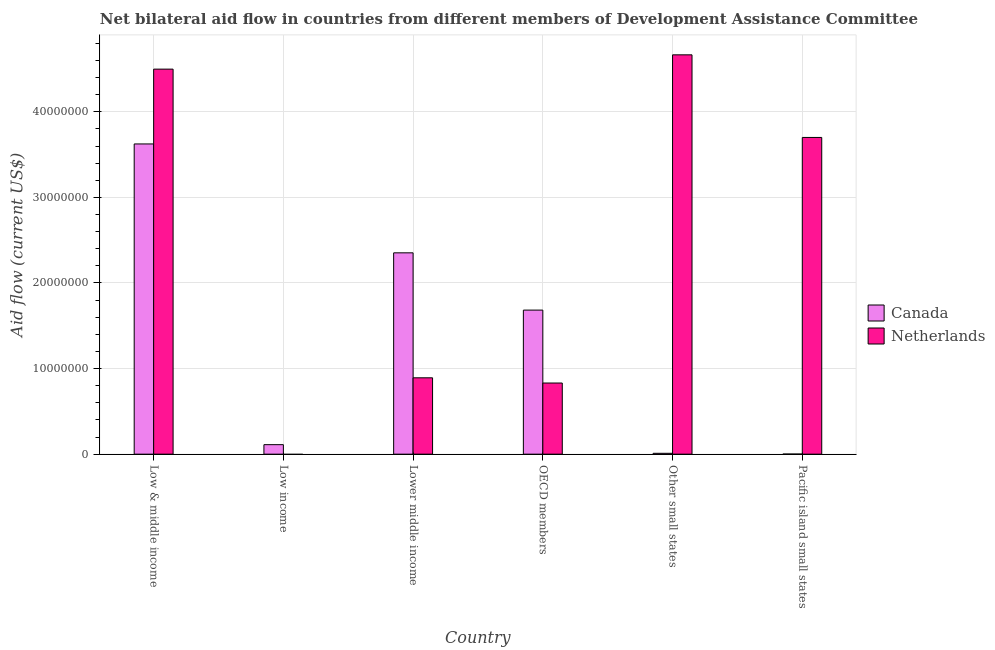How many different coloured bars are there?
Offer a very short reply. 2. Are the number of bars per tick equal to the number of legend labels?
Provide a succinct answer. No. Are the number of bars on each tick of the X-axis equal?
Your answer should be compact. No. What is the label of the 3rd group of bars from the left?
Your answer should be compact. Lower middle income. In how many cases, is the number of bars for a given country not equal to the number of legend labels?
Offer a very short reply. 1. What is the amount of aid given by netherlands in Pacific island small states?
Offer a terse response. 3.70e+07. Across all countries, what is the maximum amount of aid given by netherlands?
Ensure brevity in your answer.  4.66e+07. Across all countries, what is the minimum amount of aid given by canada?
Provide a short and direct response. 10000. What is the total amount of aid given by canada in the graph?
Your answer should be very brief. 7.78e+07. What is the difference between the amount of aid given by canada in Lower middle income and that in Pacific island small states?
Make the answer very short. 2.35e+07. What is the difference between the amount of aid given by netherlands in Low income and the amount of aid given by canada in Other small states?
Offer a very short reply. -1.00e+05. What is the average amount of aid given by netherlands per country?
Ensure brevity in your answer.  2.43e+07. What is the difference between the amount of aid given by netherlands and amount of aid given by canada in Lower middle income?
Provide a short and direct response. -1.46e+07. What is the ratio of the amount of aid given by netherlands in Low & middle income to that in Other small states?
Offer a terse response. 0.96. Is the amount of aid given by netherlands in Low & middle income less than that in Lower middle income?
Offer a very short reply. No. What is the difference between the highest and the second highest amount of aid given by canada?
Keep it short and to the point. 1.27e+07. What is the difference between the highest and the lowest amount of aid given by netherlands?
Ensure brevity in your answer.  4.66e+07. Is the sum of the amount of aid given by netherlands in Lower middle income and OECD members greater than the maximum amount of aid given by canada across all countries?
Keep it short and to the point. No. What is the difference between two consecutive major ticks on the Y-axis?
Offer a terse response. 1.00e+07. Are the values on the major ticks of Y-axis written in scientific E-notation?
Your answer should be very brief. No. Where does the legend appear in the graph?
Make the answer very short. Center right. What is the title of the graph?
Provide a succinct answer. Net bilateral aid flow in countries from different members of Development Assistance Committee. Does "National Visitors" appear as one of the legend labels in the graph?
Your answer should be compact. No. What is the label or title of the X-axis?
Give a very brief answer. Country. What is the label or title of the Y-axis?
Provide a short and direct response. Aid flow (current US$). What is the Aid flow (current US$) in Canada in Low & middle income?
Provide a succinct answer. 3.62e+07. What is the Aid flow (current US$) in Netherlands in Low & middle income?
Your answer should be compact. 4.50e+07. What is the Aid flow (current US$) of Canada in Low income?
Your answer should be compact. 1.11e+06. What is the Aid flow (current US$) in Canada in Lower middle income?
Ensure brevity in your answer.  2.35e+07. What is the Aid flow (current US$) of Netherlands in Lower middle income?
Make the answer very short. 8.92e+06. What is the Aid flow (current US$) in Canada in OECD members?
Your answer should be very brief. 1.68e+07. What is the Aid flow (current US$) of Netherlands in OECD members?
Offer a very short reply. 8.31e+06. What is the Aid flow (current US$) of Canada in Other small states?
Offer a terse response. 1.00e+05. What is the Aid flow (current US$) in Netherlands in Other small states?
Your answer should be very brief. 4.66e+07. What is the Aid flow (current US$) in Netherlands in Pacific island small states?
Keep it short and to the point. 3.70e+07. Across all countries, what is the maximum Aid flow (current US$) of Canada?
Ensure brevity in your answer.  3.62e+07. Across all countries, what is the maximum Aid flow (current US$) in Netherlands?
Your answer should be compact. 4.66e+07. Across all countries, what is the minimum Aid flow (current US$) in Canada?
Ensure brevity in your answer.  10000. Across all countries, what is the minimum Aid flow (current US$) in Netherlands?
Give a very brief answer. 0. What is the total Aid flow (current US$) in Canada in the graph?
Your response must be concise. 7.78e+07. What is the total Aid flow (current US$) of Netherlands in the graph?
Offer a terse response. 1.46e+08. What is the difference between the Aid flow (current US$) of Canada in Low & middle income and that in Low income?
Provide a succinct answer. 3.51e+07. What is the difference between the Aid flow (current US$) of Canada in Low & middle income and that in Lower middle income?
Your answer should be very brief. 1.27e+07. What is the difference between the Aid flow (current US$) of Netherlands in Low & middle income and that in Lower middle income?
Give a very brief answer. 3.61e+07. What is the difference between the Aid flow (current US$) of Canada in Low & middle income and that in OECD members?
Ensure brevity in your answer.  1.94e+07. What is the difference between the Aid flow (current US$) of Netherlands in Low & middle income and that in OECD members?
Ensure brevity in your answer.  3.67e+07. What is the difference between the Aid flow (current US$) of Canada in Low & middle income and that in Other small states?
Your answer should be very brief. 3.61e+07. What is the difference between the Aid flow (current US$) of Netherlands in Low & middle income and that in Other small states?
Give a very brief answer. -1.67e+06. What is the difference between the Aid flow (current US$) in Canada in Low & middle income and that in Pacific island small states?
Offer a terse response. 3.62e+07. What is the difference between the Aid flow (current US$) of Netherlands in Low & middle income and that in Pacific island small states?
Your answer should be compact. 7.98e+06. What is the difference between the Aid flow (current US$) in Canada in Low income and that in Lower middle income?
Provide a short and direct response. -2.24e+07. What is the difference between the Aid flow (current US$) of Canada in Low income and that in OECD members?
Your answer should be compact. -1.57e+07. What is the difference between the Aid flow (current US$) of Canada in Low income and that in Other small states?
Keep it short and to the point. 1.01e+06. What is the difference between the Aid flow (current US$) in Canada in Low income and that in Pacific island small states?
Keep it short and to the point. 1.10e+06. What is the difference between the Aid flow (current US$) in Canada in Lower middle income and that in OECD members?
Offer a terse response. 6.69e+06. What is the difference between the Aid flow (current US$) in Canada in Lower middle income and that in Other small states?
Your answer should be compact. 2.34e+07. What is the difference between the Aid flow (current US$) of Netherlands in Lower middle income and that in Other small states?
Ensure brevity in your answer.  -3.77e+07. What is the difference between the Aid flow (current US$) in Canada in Lower middle income and that in Pacific island small states?
Provide a succinct answer. 2.35e+07. What is the difference between the Aid flow (current US$) in Netherlands in Lower middle income and that in Pacific island small states?
Give a very brief answer. -2.81e+07. What is the difference between the Aid flow (current US$) in Canada in OECD members and that in Other small states?
Make the answer very short. 1.67e+07. What is the difference between the Aid flow (current US$) in Netherlands in OECD members and that in Other small states?
Provide a succinct answer. -3.83e+07. What is the difference between the Aid flow (current US$) of Canada in OECD members and that in Pacific island small states?
Provide a short and direct response. 1.68e+07. What is the difference between the Aid flow (current US$) of Netherlands in OECD members and that in Pacific island small states?
Your answer should be compact. -2.87e+07. What is the difference between the Aid flow (current US$) in Canada in Other small states and that in Pacific island small states?
Keep it short and to the point. 9.00e+04. What is the difference between the Aid flow (current US$) of Netherlands in Other small states and that in Pacific island small states?
Your response must be concise. 9.65e+06. What is the difference between the Aid flow (current US$) of Canada in Low & middle income and the Aid flow (current US$) of Netherlands in Lower middle income?
Offer a very short reply. 2.73e+07. What is the difference between the Aid flow (current US$) of Canada in Low & middle income and the Aid flow (current US$) of Netherlands in OECD members?
Offer a terse response. 2.79e+07. What is the difference between the Aid flow (current US$) in Canada in Low & middle income and the Aid flow (current US$) in Netherlands in Other small states?
Keep it short and to the point. -1.04e+07. What is the difference between the Aid flow (current US$) of Canada in Low & middle income and the Aid flow (current US$) of Netherlands in Pacific island small states?
Provide a short and direct response. -7.60e+05. What is the difference between the Aid flow (current US$) of Canada in Low income and the Aid flow (current US$) of Netherlands in Lower middle income?
Make the answer very short. -7.81e+06. What is the difference between the Aid flow (current US$) in Canada in Low income and the Aid flow (current US$) in Netherlands in OECD members?
Make the answer very short. -7.20e+06. What is the difference between the Aid flow (current US$) of Canada in Low income and the Aid flow (current US$) of Netherlands in Other small states?
Your response must be concise. -4.55e+07. What is the difference between the Aid flow (current US$) in Canada in Low income and the Aid flow (current US$) in Netherlands in Pacific island small states?
Keep it short and to the point. -3.59e+07. What is the difference between the Aid flow (current US$) of Canada in Lower middle income and the Aid flow (current US$) of Netherlands in OECD members?
Your answer should be very brief. 1.52e+07. What is the difference between the Aid flow (current US$) in Canada in Lower middle income and the Aid flow (current US$) in Netherlands in Other small states?
Your response must be concise. -2.31e+07. What is the difference between the Aid flow (current US$) of Canada in Lower middle income and the Aid flow (current US$) of Netherlands in Pacific island small states?
Provide a succinct answer. -1.35e+07. What is the difference between the Aid flow (current US$) in Canada in OECD members and the Aid flow (current US$) in Netherlands in Other small states?
Give a very brief answer. -2.98e+07. What is the difference between the Aid flow (current US$) in Canada in OECD members and the Aid flow (current US$) in Netherlands in Pacific island small states?
Your answer should be compact. -2.02e+07. What is the difference between the Aid flow (current US$) in Canada in Other small states and the Aid flow (current US$) in Netherlands in Pacific island small states?
Make the answer very short. -3.69e+07. What is the average Aid flow (current US$) of Canada per country?
Provide a short and direct response. 1.30e+07. What is the average Aid flow (current US$) of Netherlands per country?
Give a very brief answer. 2.43e+07. What is the difference between the Aid flow (current US$) of Canada and Aid flow (current US$) of Netherlands in Low & middle income?
Ensure brevity in your answer.  -8.74e+06. What is the difference between the Aid flow (current US$) of Canada and Aid flow (current US$) of Netherlands in Lower middle income?
Give a very brief answer. 1.46e+07. What is the difference between the Aid flow (current US$) in Canada and Aid flow (current US$) in Netherlands in OECD members?
Make the answer very short. 8.52e+06. What is the difference between the Aid flow (current US$) of Canada and Aid flow (current US$) of Netherlands in Other small states?
Keep it short and to the point. -4.66e+07. What is the difference between the Aid flow (current US$) of Canada and Aid flow (current US$) of Netherlands in Pacific island small states?
Your answer should be very brief. -3.70e+07. What is the ratio of the Aid flow (current US$) of Canada in Low & middle income to that in Low income?
Provide a succinct answer. 32.65. What is the ratio of the Aid flow (current US$) of Canada in Low & middle income to that in Lower middle income?
Make the answer very short. 1.54. What is the ratio of the Aid flow (current US$) in Netherlands in Low & middle income to that in Lower middle income?
Ensure brevity in your answer.  5.04. What is the ratio of the Aid flow (current US$) of Canada in Low & middle income to that in OECD members?
Ensure brevity in your answer.  2.15. What is the ratio of the Aid flow (current US$) of Netherlands in Low & middle income to that in OECD members?
Provide a succinct answer. 5.41. What is the ratio of the Aid flow (current US$) in Canada in Low & middle income to that in Other small states?
Ensure brevity in your answer.  362.4. What is the ratio of the Aid flow (current US$) of Netherlands in Low & middle income to that in Other small states?
Your response must be concise. 0.96. What is the ratio of the Aid flow (current US$) in Canada in Low & middle income to that in Pacific island small states?
Provide a short and direct response. 3624. What is the ratio of the Aid flow (current US$) in Netherlands in Low & middle income to that in Pacific island small states?
Offer a terse response. 1.22. What is the ratio of the Aid flow (current US$) in Canada in Low income to that in Lower middle income?
Make the answer very short. 0.05. What is the ratio of the Aid flow (current US$) in Canada in Low income to that in OECD members?
Make the answer very short. 0.07. What is the ratio of the Aid flow (current US$) of Canada in Low income to that in Other small states?
Your answer should be compact. 11.1. What is the ratio of the Aid flow (current US$) in Canada in Low income to that in Pacific island small states?
Your answer should be very brief. 111. What is the ratio of the Aid flow (current US$) in Canada in Lower middle income to that in OECD members?
Offer a very short reply. 1.4. What is the ratio of the Aid flow (current US$) in Netherlands in Lower middle income to that in OECD members?
Provide a succinct answer. 1.07. What is the ratio of the Aid flow (current US$) of Canada in Lower middle income to that in Other small states?
Provide a succinct answer. 235.2. What is the ratio of the Aid flow (current US$) in Netherlands in Lower middle income to that in Other small states?
Provide a short and direct response. 0.19. What is the ratio of the Aid flow (current US$) of Canada in Lower middle income to that in Pacific island small states?
Provide a short and direct response. 2352. What is the ratio of the Aid flow (current US$) in Netherlands in Lower middle income to that in Pacific island small states?
Your response must be concise. 0.24. What is the ratio of the Aid flow (current US$) of Canada in OECD members to that in Other small states?
Your answer should be compact. 168.3. What is the ratio of the Aid flow (current US$) in Netherlands in OECD members to that in Other small states?
Offer a very short reply. 0.18. What is the ratio of the Aid flow (current US$) of Canada in OECD members to that in Pacific island small states?
Keep it short and to the point. 1683. What is the ratio of the Aid flow (current US$) in Netherlands in OECD members to that in Pacific island small states?
Offer a very short reply. 0.22. What is the ratio of the Aid flow (current US$) in Canada in Other small states to that in Pacific island small states?
Offer a very short reply. 10. What is the ratio of the Aid flow (current US$) of Netherlands in Other small states to that in Pacific island small states?
Keep it short and to the point. 1.26. What is the difference between the highest and the second highest Aid flow (current US$) of Canada?
Give a very brief answer. 1.27e+07. What is the difference between the highest and the second highest Aid flow (current US$) of Netherlands?
Your response must be concise. 1.67e+06. What is the difference between the highest and the lowest Aid flow (current US$) of Canada?
Provide a succinct answer. 3.62e+07. What is the difference between the highest and the lowest Aid flow (current US$) of Netherlands?
Provide a succinct answer. 4.66e+07. 